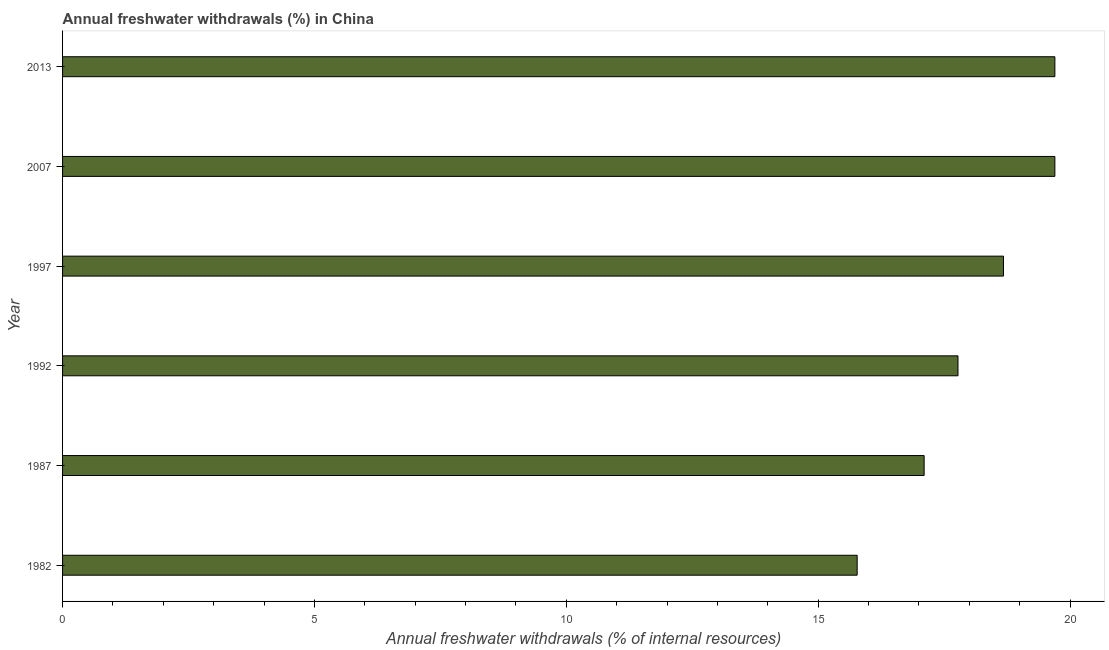Does the graph contain any zero values?
Offer a terse response. No. Does the graph contain grids?
Provide a short and direct response. No. What is the title of the graph?
Provide a short and direct response. Annual freshwater withdrawals (%) in China. What is the label or title of the X-axis?
Make the answer very short. Annual freshwater withdrawals (% of internal resources). What is the label or title of the Y-axis?
Keep it short and to the point. Year. What is the annual freshwater withdrawals in 1987?
Your answer should be very brief. 17.1. Across all years, what is the maximum annual freshwater withdrawals?
Offer a very short reply. 19.7. Across all years, what is the minimum annual freshwater withdrawals?
Offer a terse response. 15.77. What is the sum of the annual freshwater withdrawals?
Ensure brevity in your answer.  108.72. What is the difference between the annual freshwater withdrawals in 1982 and 2013?
Provide a succinct answer. -3.92. What is the average annual freshwater withdrawals per year?
Provide a succinct answer. 18.12. What is the median annual freshwater withdrawals?
Give a very brief answer. 18.23. What is the ratio of the annual freshwater withdrawals in 1992 to that in 2007?
Make the answer very short. 0.9. Is the sum of the annual freshwater withdrawals in 1982 and 1987 greater than the maximum annual freshwater withdrawals across all years?
Provide a succinct answer. Yes. What is the difference between the highest and the lowest annual freshwater withdrawals?
Ensure brevity in your answer.  3.92. In how many years, is the annual freshwater withdrawals greater than the average annual freshwater withdrawals taken over all years?
Ensure brevity in your answer.  3. How many bars are there?
Provide a succinct answer. 6. Are all the bars in the graph horizontal?
Keep it short and to the point. Yes. What is the Annual freshwater withdrawals (% of internal resources) in 1982?
Provide a short and direct response. 15.77. What is the Annual freshwater withdrawals (% of internal resources) of 1987?
Make the answer very short. 17.1. What is the Annual freshwater withdrawals (% of internal resources) in 1992?
Make the answer very short. 17.77. What is the Annual freshwater withdrawals (% of internal resources) of 1997?
Ensure brevity in your answer.  18.68. What is the Annual freshwater withdrawals (% of internal resources) in 2007?
Make the answer very short. 19.7. What is the Annual freshwater withdrawals (% of internal resources) of 2013?
Ensure brevity in your answer.  19.7. What is the difference between the Annual freshwater withdrawals (% of internal resources) in 1982 and 1987?
Your answer should be very brief. -1.33. What is the difference between the Annual freshwater withdrawals (% of internal resources) in 1982 and 1992?
Offer a very short reply. -2. What is the difference between the Annual freshwater withdrawals (% of internal resources) in 1982 and 1997?
Provide a short and direct response. -2.9. What is the difference between the Annual freshwater withdrawals (% of internal resources) in 1982 and 2007?
Your answer should be very brief. -3.92. What is the difference between the Annual freshwater withdrawals (% of internal resources) in 1982 and 2013?
Ensure brevity in your answer.  -3.92. What is the difference between the Annual freshwater withdrawals (% of internal resources) in 1987 and 1992?
Make the answer very short. -0.67. What is the difference between the Annual freshwater withdrawals (% of internal resources) in 1987 and 1997?
Your answer should be compact. -1.57. What is the difference between the Annual freshwater withdrawals (% of internal resources) in 1987 and 2007?
Ensure brevity in your answer.  -2.6. What is the difference between the Annual freshwater withdrawals (% of internal resources) in 1987 and 2013?
Your response must be concise. -2.6. What is the difference between the Annual freshwater withdrawals (% of internal resources) in 1992 and 1997?
Make the answer very short. -0.9. What is the difference between the Annual freshwater withdrawals (% of internal resources) in 1992 and 2007?
Offer a terse response. -1.92. What is the difference between the Annual freshwater withdrawals (% of internal resources) in 1992 and 2013?
Offer a very short reply. -1.92. What is the difference between the Annual freshwater withdrawals (% of internal resources) in 1997 and 2007?
Ensure brevity in your answer.  -1.02. What is the difference between the Annual freshwater withdrawals (% of internal resources) in 1997 and 2013?
Ensure brevity in your answer.  -1.02. What is the difference between the Annual freshwater withdrawals (% of internal resources) in 2007 and 2013?
Your response must be concise. 0. What is the ratio of the Annual freshwater withdrawals (% of internal resources) in 1982 to that in 1987?
Keep it short and to the point. 0.92. What is the ratio of the Annual freshwater withdrawals (% of internal resources) in 1982 to that in 1992?
Offer a terse response. 0.89. What is the ratio of the Annual freshwater withdrawals (% of internal resources) in 1982 to that in 1997?
Provide a succinct answer. 0.84. What is the ratio of the Annual freshwater withdrawals (% of internal resources) in 1982 to that in 2007?
Make the answer very short. 0.8. What is the ratio of the Annual freshwater withdrawals (% of internal resources) in 1982 to that in 2013?
Keep it short and to the point. 0.8. What is the ratio of the Annual freshwater withdrawals (% of internal resources) in 1987 to that in 1997?
Provide a succinct answer. 0.92. What is the ratio of the Annual freshwater withdrawals (% of internal resources) in 1987 to that in 2007?
Provide a succinct answer. 0.87. What is the ratio of the Annual freshwater withdrawals (% of internal resources) in 1987 to that in 2013?
Keep it short and to the point. 0.87. What is the ratio of the Annual freshwater withdrawals (% of internal resources) in 1992 to that in 2007?
Make the answer very short. 0.9. What is the ratio of the Annual freshwater withdrawals (% of internal resources) in 1992 to that in 2013?
Make the answer very short. 0.9. What is the ratio of the Annual freshwater withdrawals (% of internal resources) in 1997 to that in 2007?
Provide a succinct answer. 0.95. What is the ratio of the Annual freshwater withdrawals (% of internal resources) in 1997 to that in 2013?
Your response must be concise. 0.95. 